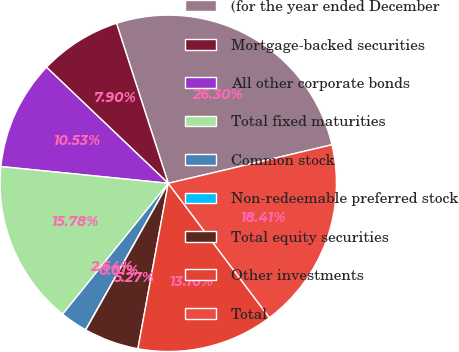Convert chart to OTSL. <chart><loc_0><loc_0><loc_500><loc_500><pie_chart><fcel>(for the year ended December<fcel>Mortgage-backed securities<fcel>All other corporate bonds<fcel>Total fixed maturities<fcel>Common stock<fcel>Non-redeemable preferred stock<fcel>Total equity securities<fcel>Other investments<fcel>Total<nl><fcel>26.3%<fcel>7.9%<fcel>10.53%<fcel>15.78%<fcel>2.64%<fcel>0.01%<fcel>5.27%<fcel>13.16%<fcel>18.41%<nl></chart> 